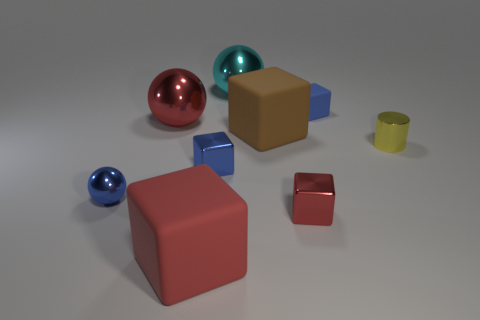What is the shape of the big red matte object?
Your response must be concise. Cube. There is a big rubber thing that is behind the yellow cylinder; does it have the same color as the tiny shiny cylinder?
Keep it short and to the point. No. There is a brown object that is the same shape as the small red shiny object; what is its size?
Your answer should be compact. Large. Is there any other thing that is made of the same material as the tiny red cube?
Your response must be concise. Yes. Are there any blue objects that are in front of the large matte thing that is to the right of the matte thing that is in front of the yellow thing?
Make the answer very short. Yes. There is a small blue object to the right of the blue shiny block; what material is it?
Provide a succinct answer. Rubber. What number of big objects are either things or red rubber objects?
Provide a short and direct response. 4. There is a blue metallic object left of the red matte object; does it have the same size as the small yellow metallic cylinder?
Provide a short and direct response. Yes. What number of other objects are the same color as the small sphere?
Give a very brief answer. 2. What is the cylinder made of?
Provide a short and direct response. Metal. 